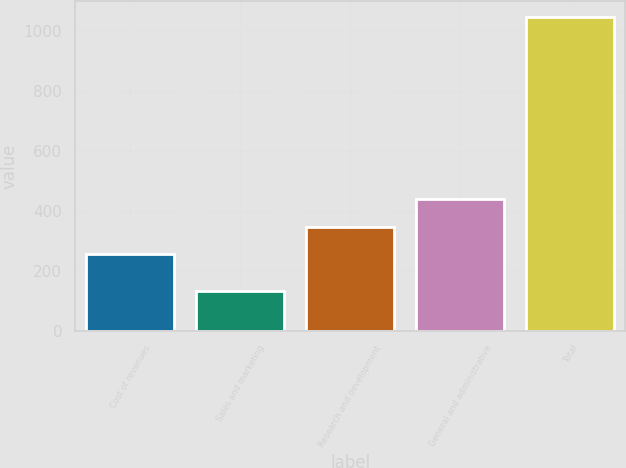Convert chart to OTSL. <chart><loc_0><loc_0><loc_500><loc_500><bar_chart><fcel>Cost of revenues<fcel>Sales and marketing<fcel>Research and development<fcel>General and administrative<fcel>Total<nl><fcel>256<fcel>133<fcel>347.5<fcel>439<fcel>1048<nl></chart> 